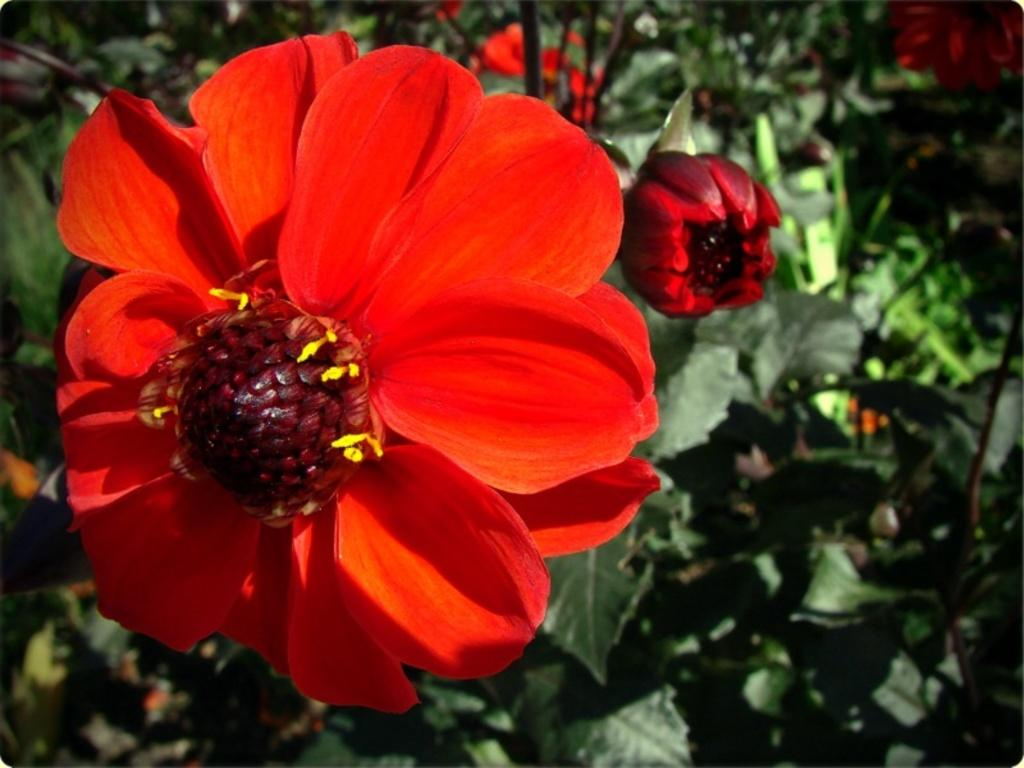What type of flowers can be seen in the image? There are red-colored flowers in the image. Where are the flowers located? The flowers are present on a plant. What type of fork is used to help the flowers grow in the image? There is no fork present in the image, and forks are not used to help flowers grow. 